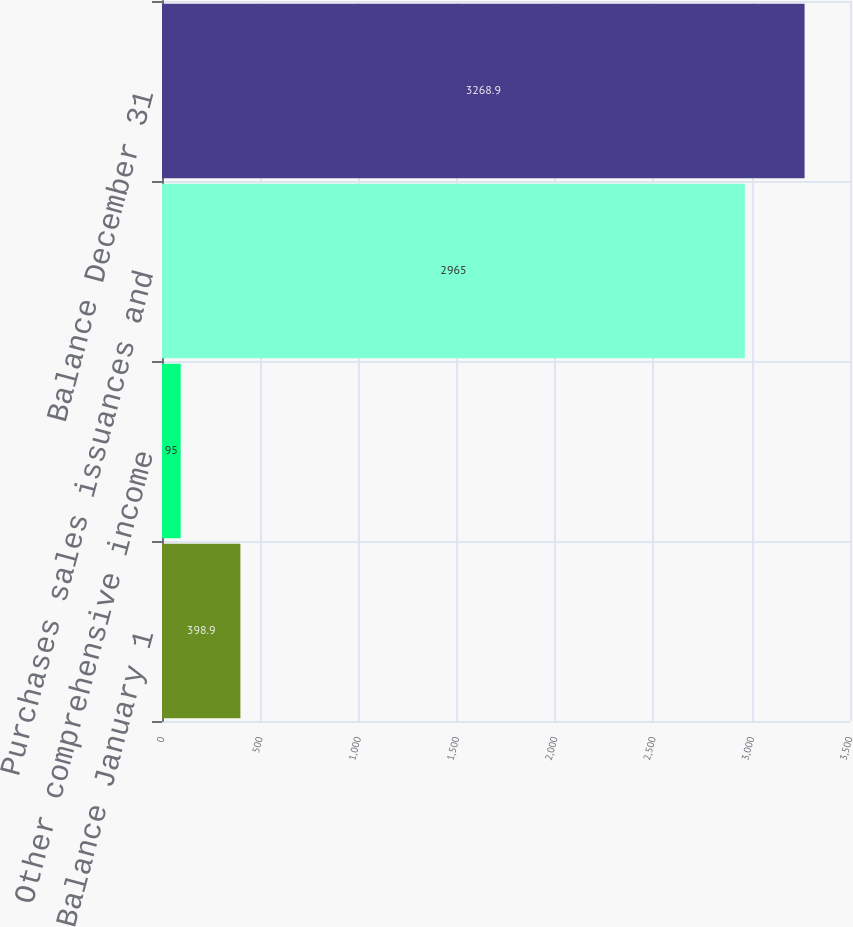Convert chart. <chart><loc_0><loc_0><loc_500><loc_500><bar_chart><fcel>Balance January 1<fcel>Other comprehensive income<fcel>Purchases sales issuances and<fcel>Balance December 31<nl><fcel>398.9<fcel>95<fcel>2965<fcel>3268.9<nl></chart> 